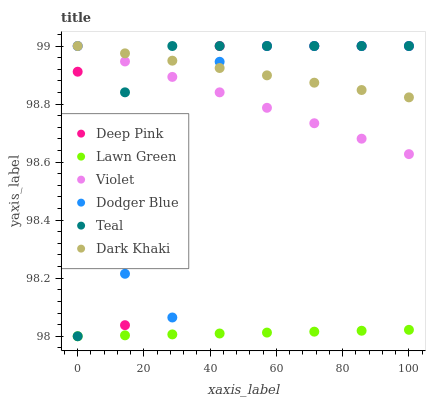Does Lawn Green have the minimum area under the curve?
Answer yes or no. Yes. Does Dark Khaki have the maximum area under the curve?
Answer yes or no. Yes. Does Deep Pink have the minimum area under the curve?
Answer yes or no. No. Does Deep Pink have the maximum area under the curve?
Answer yes or no. No. Is Violet the smoothest?
Answer yes or no. Yes. Is Dodger Blue the roughest?
Answer yes or no. Yes. Is Deep Pink the smoothest?
Answer yes or no. No. Is Deep Pink the roughest?
Answer yes or no. No. Does Lawn Green have the lowest value?
Answer yes or no. Yes. Does Deep Pink have the lowest value?
Answer yes or no. No. Does Violet have the highest value?
Answer yes or no. Yes. Is Lawn Green less than Dodger Blue?
Answer yes or no. Yes. Is Teal greater than Lawn Green?
Answer yes or no. Yes. Does Deep Pink intersect Dodger Blue?
Answer yes or no. Yes. Is Deep Pink less than Dodger Blue?
Answer yes or no. No. Is Deep Pink greater than Dodger Blue?
Answer yes or no. No. Does Lawn Green intersect Dodger Blue?
Answer yes or no. No. 